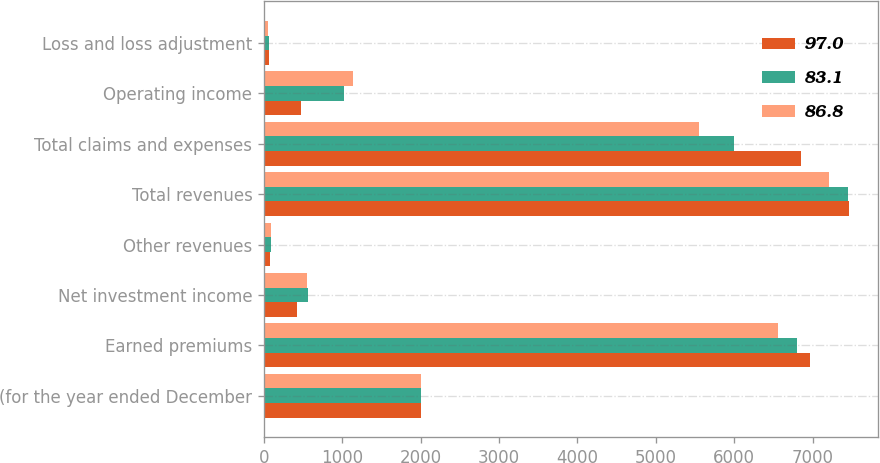<chart> <loc_0><loc_0><loc_500><loc_500><stacked_bar_chart><ecel><fcel>(for the year ended December<fcel>Earned premiums<fcel>Net investment income<fcel>Other revenues<fcel>Total revenues<fcel>Total claims and expenses<fcel>Operating income<fcel>Loss and loss adjustment<nl><fcel>97<fcel>2008<fcel>6970<fcel>421<fcel>75<fcel>7466<fcel>6855<fcel>465<fcel>66.2<nl><fcel>83.1<fcel>2007<fcel>6803<fcel>559<fcel>90<fcel>7452<fcel>5996<fcel>1019<fcel>58.6<nl><fcel>86.8<fcel>2006<fcel>6563<fcel>548<fcel>94<fcel>7205<fcel>5555<fcel>1132<fcel>54.8<nl></chart> 